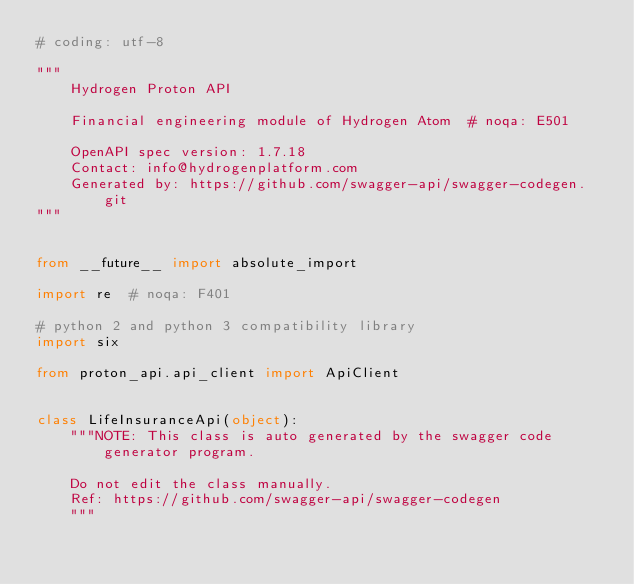<code> <loc_0><loc_0><loc_500><loc_500><_Python_># coding: utf-8

"""
    Hydrogen Proton API

    Financial engineering module of Hydrogen Atom  # noqa: E501

    OpenAPI spec version: 1.7.18
    Contact: info@hydrogenplatform.com
    Generated by: https://github.com/swagger-api/swagger-codegen.git
"""


from __future__ import absolute_import

import re  # noqa: F401

# python 2 and python 3 compatibility library
import six

from proton_api.api_client import ApiClient


class LifeInsuranceApi(object):
    """NOTE: This class is auto generated by the swagger code generator program.

    Do not edit the class manually.
    Ref: https://github.com/swagger-api/swagger-codegen
    """
</code> 